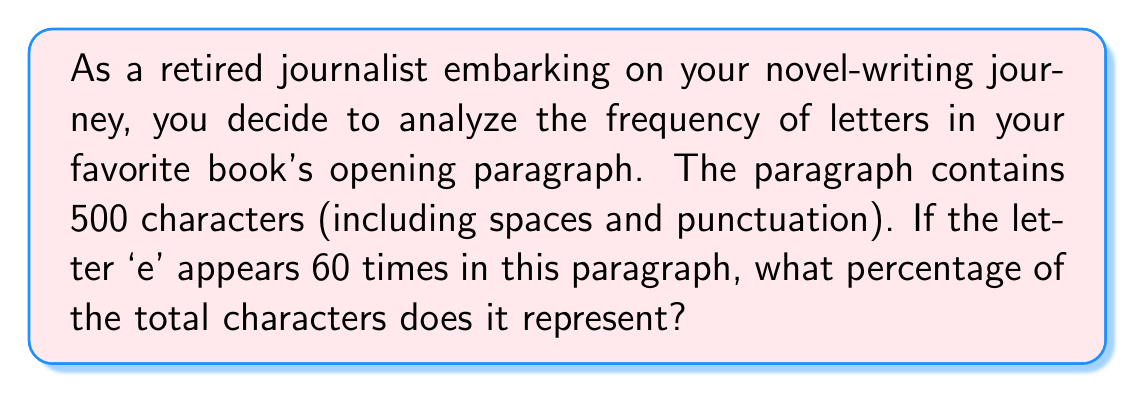Help me with this question. To solve this problem, we need to follow these steps:

1. Identify the total number of characters: 500

2. Identify the number of times 'e' appears: 60

3. Calculate the percentage using the formula:
   $$ \text{Percentage} = \frac{\text{Number of occurrences}}{\text{Total characters}} \times 100\% $$

4. Plug in the values:
   $$ \text{Percentage} = \frac{60}{500} \times 100\% $$

5. Simplify the fraction:
   $$ \text{Percentage} = \frac{3}{25} \times 100\% $$

6. Perform the multiplication:
   $$ \text{Percentage} = 12\% $$

Therefore, the letter 'e' represents 12% of the total characters in the paragraph.
Answer: 12% 